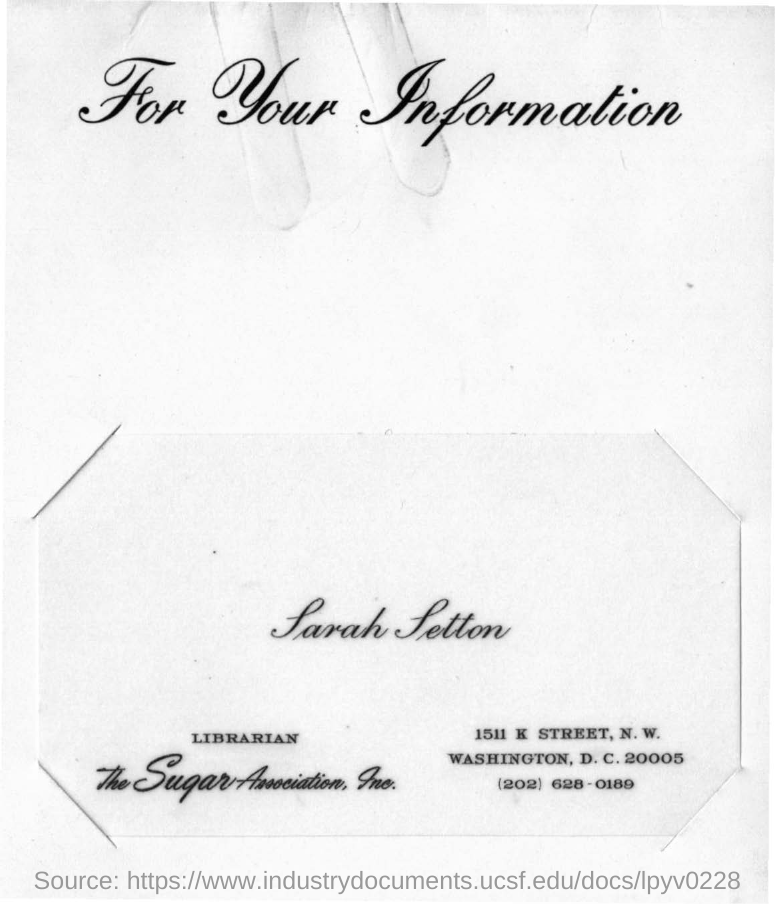Mention a couple of crucial points in this snapshot. Sarah Setton is the librarian of The Sugar Association, Inc. 